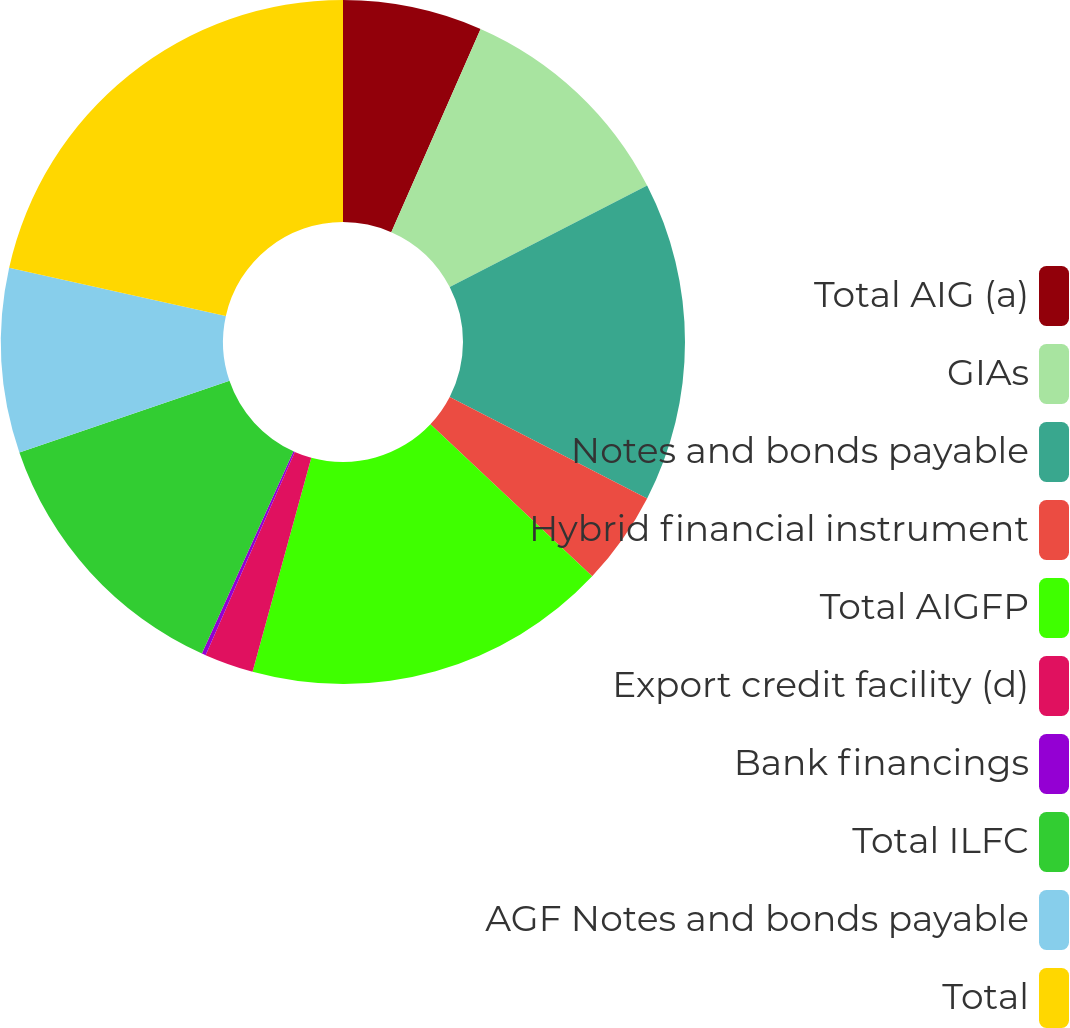<chart> <loc_0><loc_0><loc_500><loc_500><pie_chart><fcel>Total AIG (a)<fcel>GIAs<fcel>Notes and bonds payable<fcel>Hybrid financial instrument<fcel>Total AIGFP<fcel>Export credit facility (d)<fcel>Bank financings<fcel>Total ILFC<fcel>AGF Notes and bonds payable<fcel>Total<nl><fcel>6.59%<fcel>10.85%<fcel>15.12%<fcel>4.45%<fcel>17.25%<fcel>2.32%<fcel>0.19%<fcel>12.99%<fcel>8.72%<fcel>21.52%<nl></chart> 